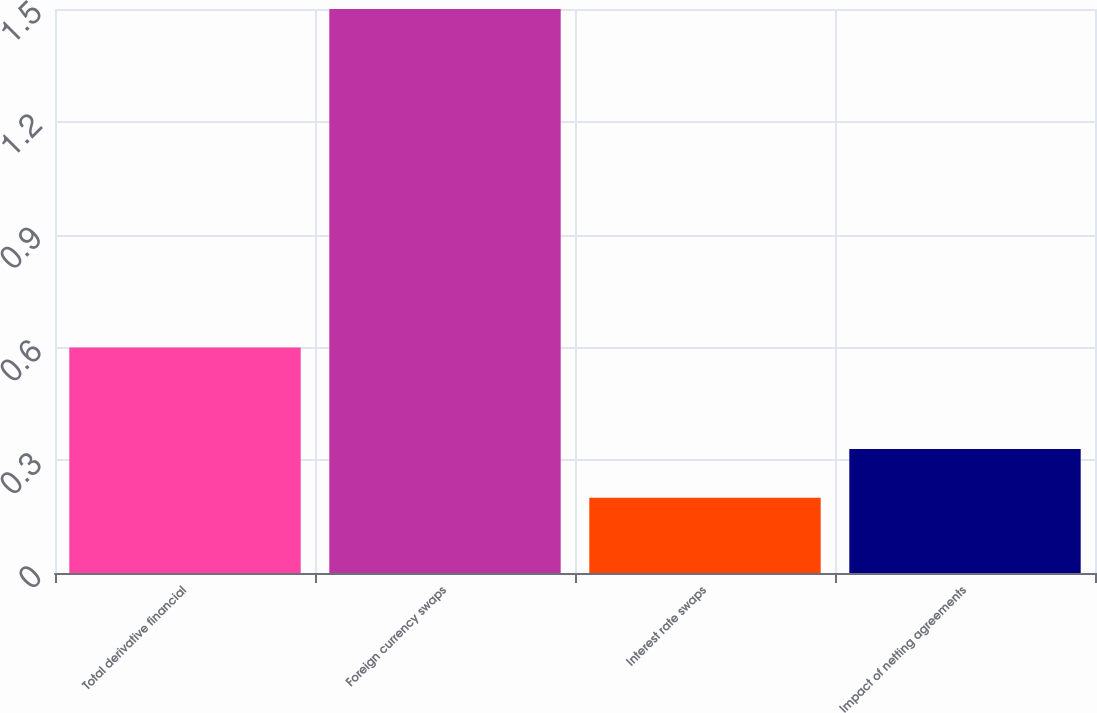Convert chart to OTSL. <chart><loc_0><loc_0><loc_500><loc_500><bar_chart><fcel>Total derivative financial<fcel>Foreign currency swaps<fcel>Interest rate swaps<fcel>Impact of netting agreements<nl><fcel>0.6<fcel>1.5<fcel>0.2<fcel>0.33<nl></chart> 